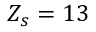<formula> <loc_0><loc_0><loc_500><loc_500>Z _ { s } = 1 3</formula> 